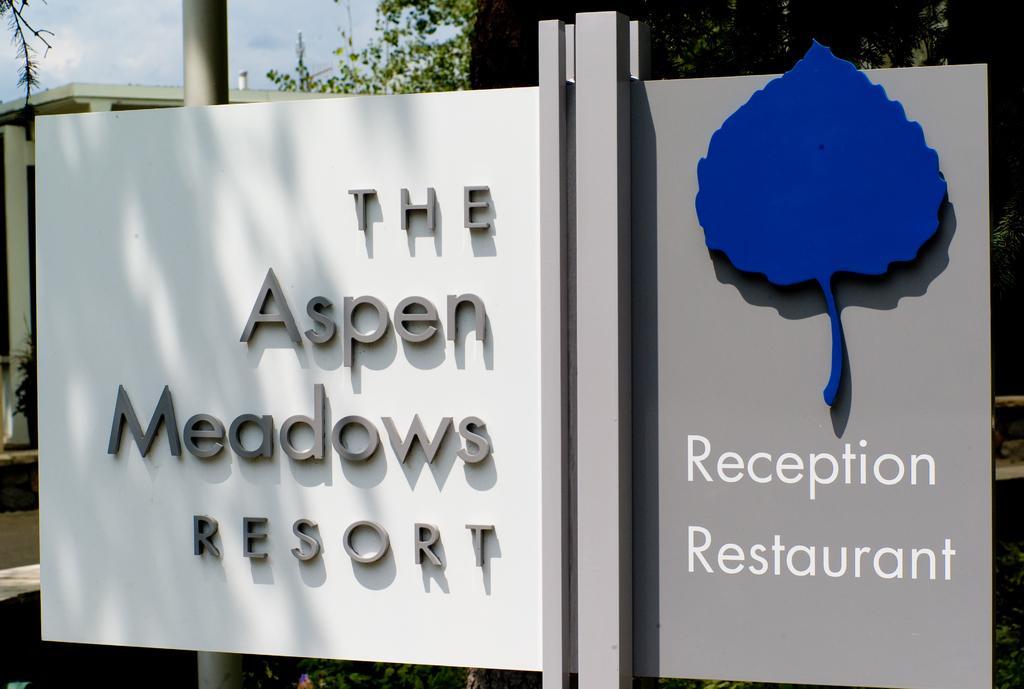Can you describe this image briefly? In the image we can see a banner. Behind the banner we can see some poles, trees and buildings. At the top left corner of the image we can see some clouds in the sky. 